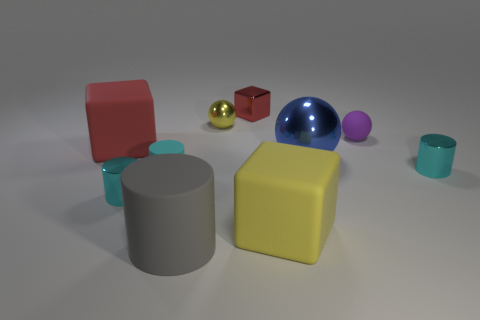Subtract all purple blocks. How many cyan cylinders are left? 3 Subtract all tiny yellow metallic balls. How many balls are left? 2 Subtract 1 balls. How many balls are left? 2 Subtract all gray cylinders. How many cylinders are left? 3 Subtract all green cylinders. Subtract all brown spheres. How many cylinders are left? 4 Subtract all tiny purple spheres. Subtract all red metal blocks. How many objects are left? 8 Add 9 cyan rubber objects. How many cyan rubber objects are left? 10 Add 8 tiny blue matte cylinders. How many tiny blue matte cylinders exist? 8 Subtract 0 brown blocks. How many objects are left? 10 Subtract all blocks. How many objects are left? 7 